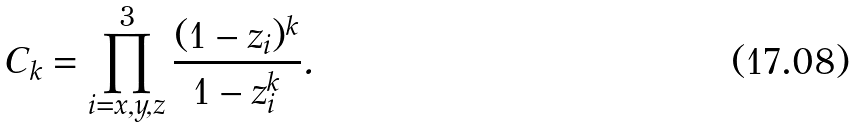Convert formula to latex. <formula><loc_0><loc_0><loc_500><loc_500>C _ { k } = \prod _ { i = x , y , z } ^ { 3 } \frac { ( 1 - z _ { i } ) ^ { k } } { 1 - z _ { i } ^ { k } } .</formula> 